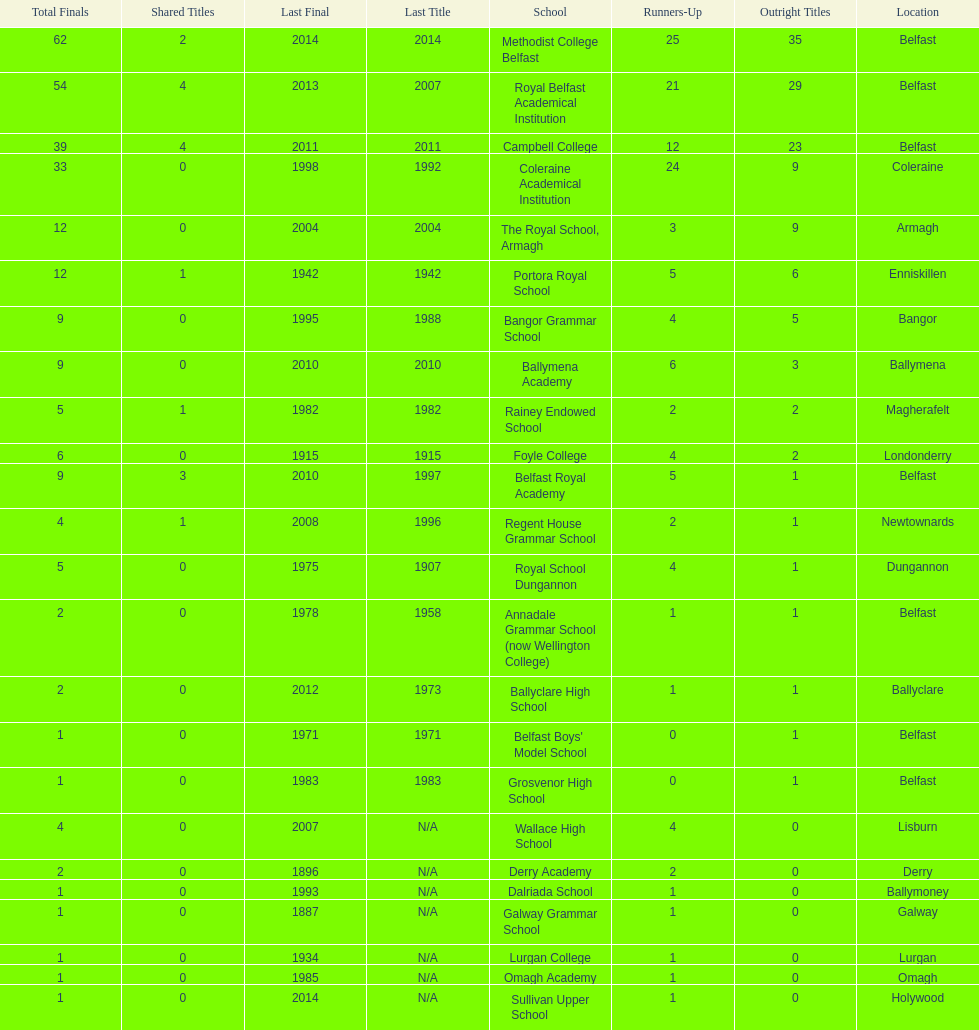Which schools have the largest number of shared titles? Royal Belfast Academical Institution, Campbell College. 